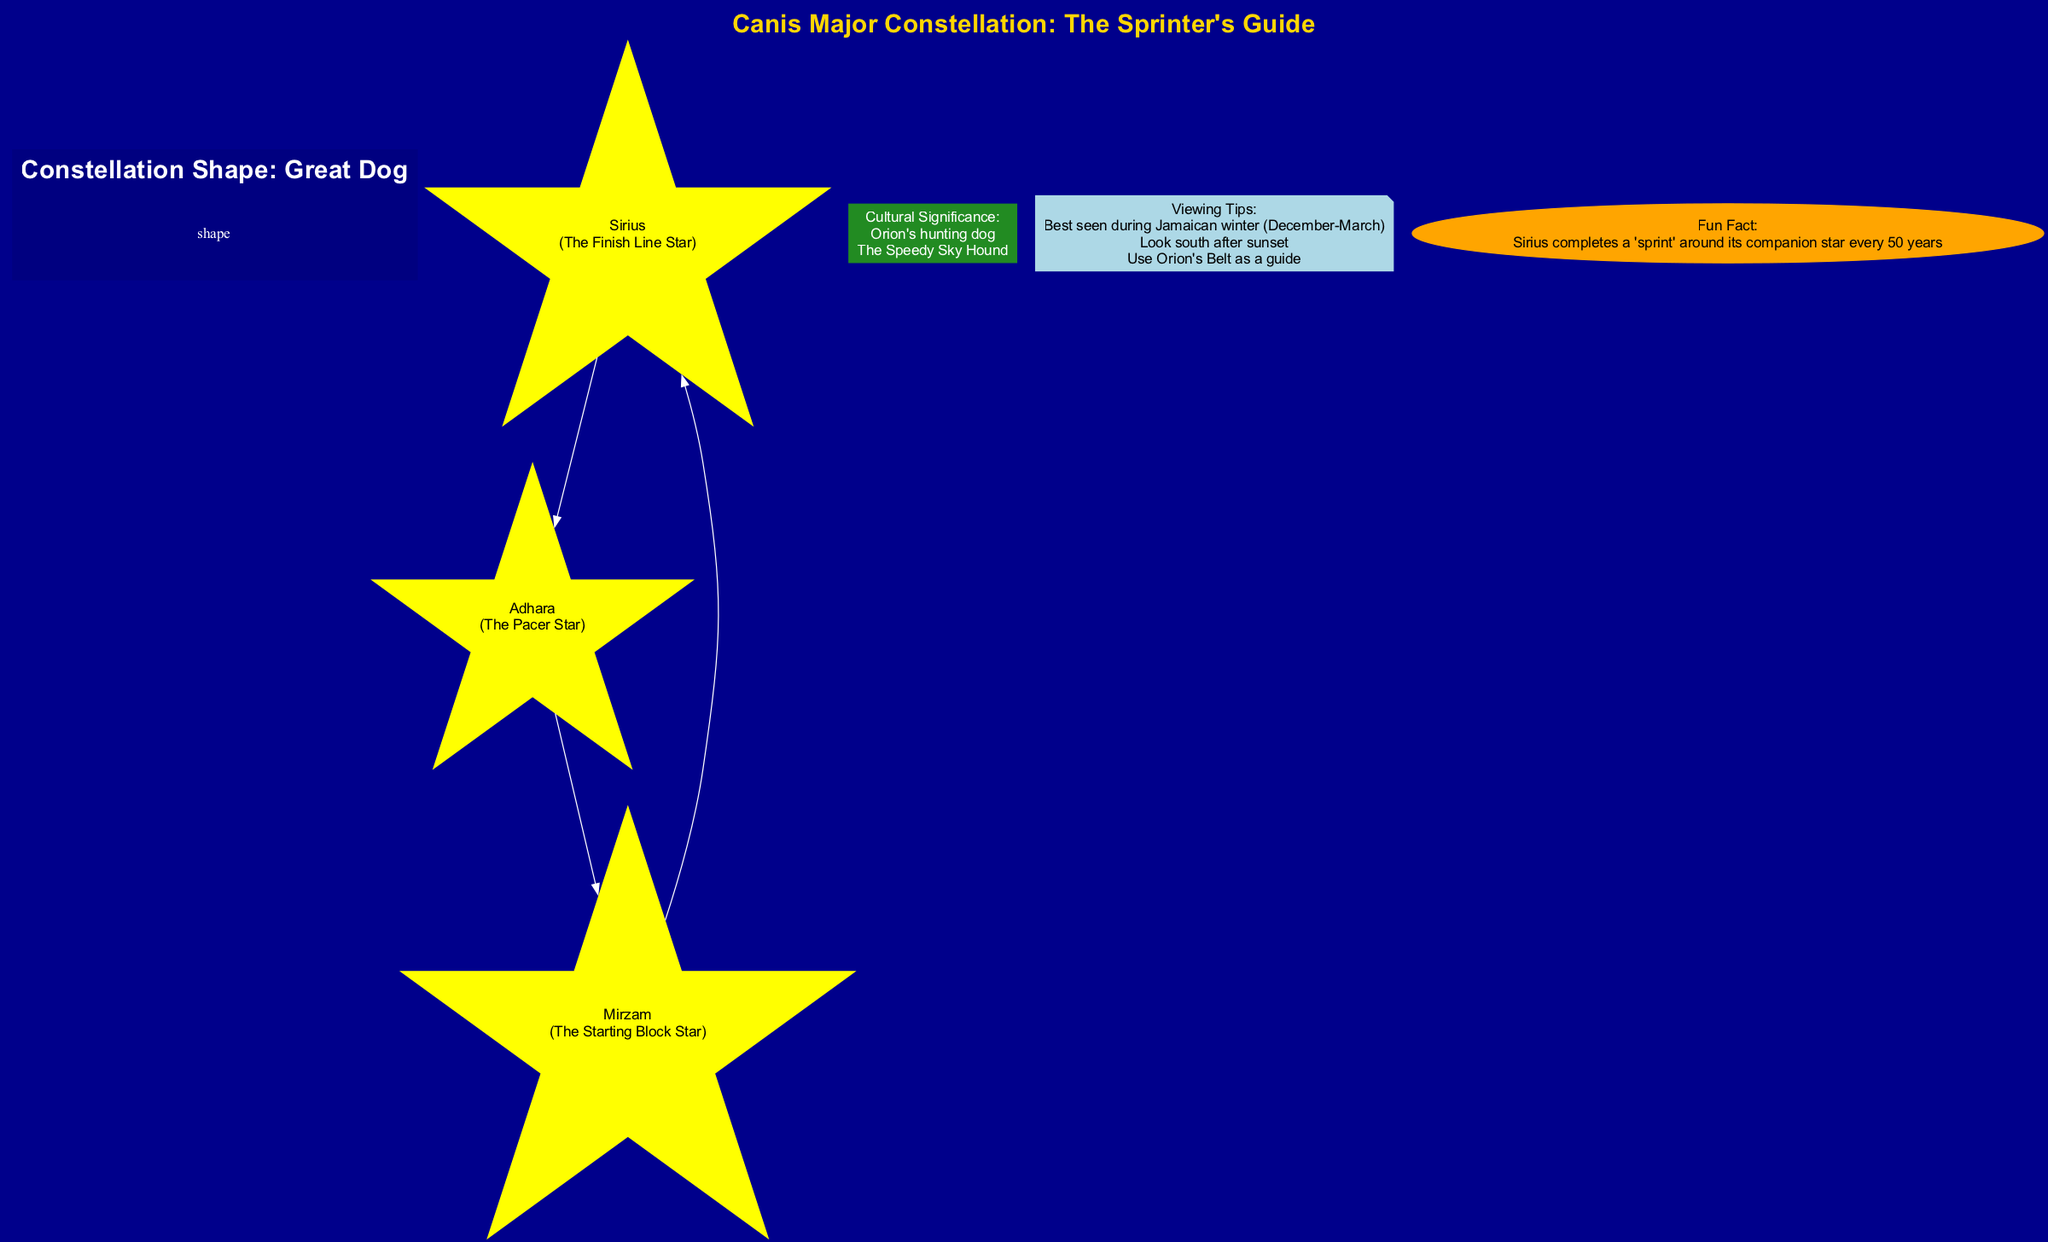What is the brightest star in the diagram? The diagram highlights Sirius as the brightest star in Earth's night sky, explicitly stating this in its description.
Answer: Sirius How many main stars are labeled in the constellation? The diagram lists three main stars: Sirius, Adhara, and Mirzam. Thus, by counting these elements, the answer is three.
Answer: 3 What is the nickname of Adhara? Adhara is described in the diagram with the nickname "The Pacer Star", clearly stated in the star's details.
Answer: The Pacer Star What shape does the constellation Canis Major take? The diagram denotes the shape of the constellation as "Great Dog". This information is emphasized in the section related to the constellation's shape.
Answer: Great Dog What is the cultural significance of Canis Major according to the diagram? According to the diagram, the cultural significance denotes Orion's hunting dog, as also highlighted under cultural significance.
Answer: Orion's hunting dog How should one locate Canis Major in the sky according to the viewing tips? The diagram provides specific tips, including "Look south after sunset" which directly guides viewers on where to look to find the constellation.
Answer: Look south after sunset What is the fun fact mentioned about Sirius? The diagram mentions that Sirius completes a "sprint" around its companion star every 50 years, making this an interesting detail.
Answer: Every 50 years What color is used for the constellation shape in the diagram? In the diagram, the color representing the constellation shape is navy, as indicated under the attributes of the cluster for the constellation shape.
Answer: Navy Which star is referred to as "The Starting Block Star"? The diagram indicates that Mirzam carries the nickname "The Starting Block Star", which is stated explicitly in its description.
Answer: The Starting Block Star 